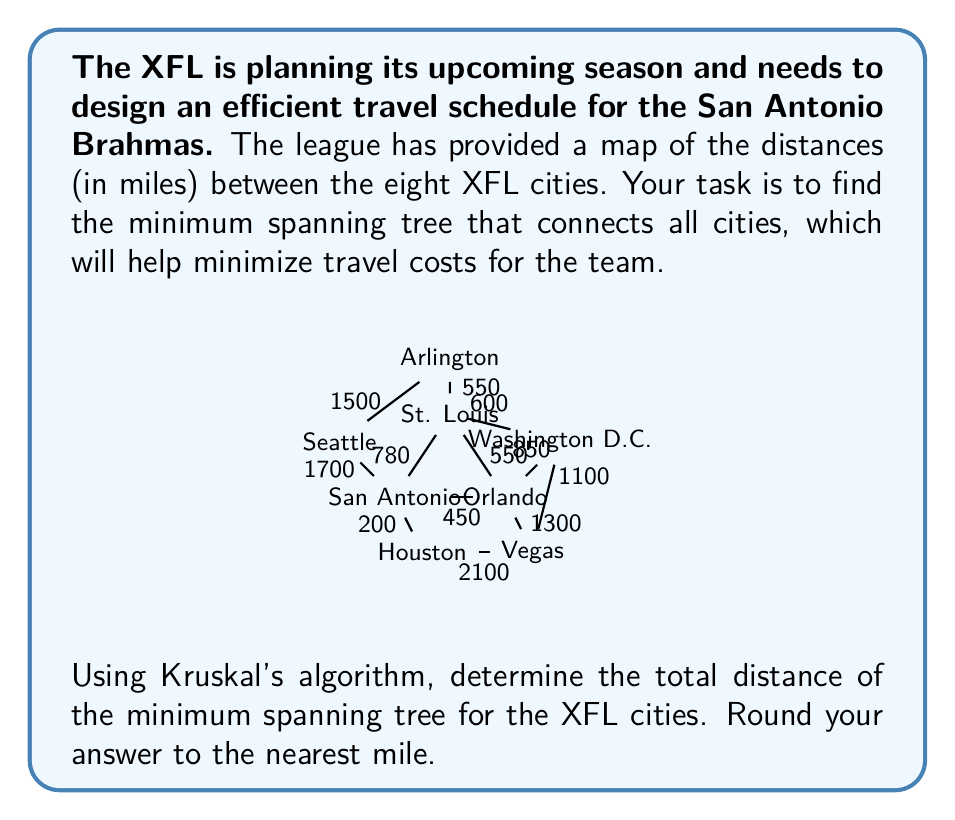Teach me how to tackle this problem. To solve this problem, we'll use Kruskal's algorithm to find the minimum spanning tree (MST) of the given graph. Here's a step-by-step explanation:

1) First, we list all edges in ascending order of weight (distance):
   - San Antonio - Houston: 200 miles
   - San Antonio - Orlando: 450 miles
   - Orlando - St. Louis: 550 miles
   - St. Louis - Arlington: 550 miles
   - St. Louis - Washington D.C.: 600 miles
   - San Antonio - St. Louis: 780 miles
   - Orlando - Washington D.C.: 850 miles
   - Houston - Vegas: 2100 miles
   - Orlando - Vegas: 1300 miles
   - Seattle - Arlington: 1500 miles
   - San Antonio - Seattle: 1700 miles
   - Washington D.C. - Vegas: 1100 miles

2) Now, we'll add edges to our MST, starting with the shortest, as long as they don't create a cycle:

   a) San Antonio - Houston: 200 miles (added)
   b) San Antonio - Orlando: 450 miles (added)
   c) Orlando - St. Louis: 550 miles (added)
   d) St. Louis - Arlington: 550 miles (added)
   e) St. Louis - Washington D.C.: 600 miles (added)
   f) San Antonio - St. Louis: 780 miles (not added, creates a cycle)
   g) Orlando - Washington D.C.: 850 miles (not added, creates a cycle)
   h) Washington D.C. - Vegas: 1100 miles (added)
   i) Seattle - Arlington: 1500 miles (added)

3) We stop here because we've connected all 8 cities with 7 edges, which is the definition of a tree.

4) To get the total distance, we sum up the distances of the edges in our MST:
   
   $$200 + 450 + 550 + 550 + 600 + 1100 + 1500 = 4950$$ miles

Therefore, the total distance of the minimum spanning tree is 4,950 miles.
Answer: 4,950 miles 